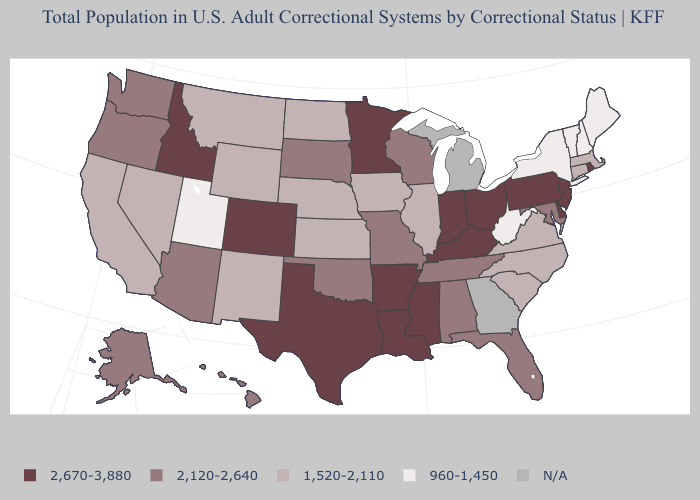Name the states that have a value in the range 960-1,450?
Quick response, please. Maine, New Hampshire, New York, Utah, Vermont, West Virginia. Among the states that border Georgia , does North Carolina have the highest value?
Quick response, please. No. What is the value of Pennsylvania?
Quick response, please. 2,670-3,880. Name the states that have a value in the range 2,120-2,640?
Concise answer only. Alabama, Alaska, Arizona, Florida, Hawaii, Maryland, Missouri, Oklahoma, Oregon, South Dakota, Tennessee, Washington, Wisconsin. Which states have the lowest value in the South?
Quick response, please. West Virginia. Which states hav the highest value in the MidWest?
Write a very short answer. Indiana, Minnesota, Ohio. Name the states that have a value in the range 1,520-2,110?
Write a very short answer. California, Connecticut, Illinois, Iowa, Kansas, Massachusetts, Montana, Nebraska, Nevada, New Mexico, North Carolina, North Dakota, South Carolina, Virginia, Wyoming. Which states have the lowest value in the USA?
Concise answer only. Maine, New Hampshire, New York, Utah, Vermont, West Virginia. What is the value of Oregon?
Keep it brief. 2,120-2,640. Does North Carolina have the highest value in the USA?
Write a very short answer. No. What is the value of New Jersey?
Give a very brief answer. 2,670-3,880. Among the states that border Indiana , which have the lowest value?
Keep it brief. Illinois. What is the value of Louisiana?
Short answer required. 2,670-3,880. Does the first symbol in the legend represent the smallest category?
Concise answer only. No. 